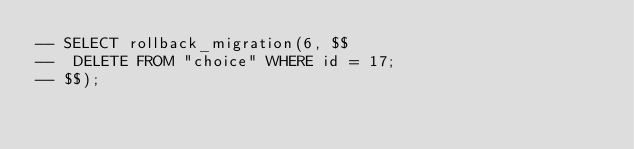<code> <loc_0><loc_0><loc_500><loc_500><_SQL_>-- SELECT rollback_migration(6, $$
-- 	DELETE FROM "choice" WHERE id = 17;
-- $$);</code> 